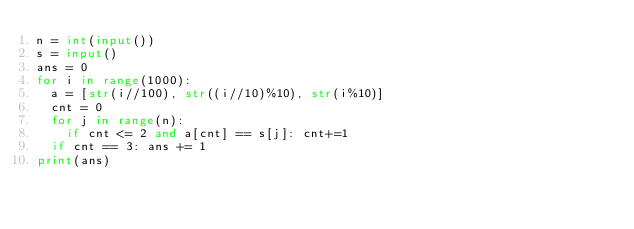Convert code to text. <code><loc_0><loc_0><loc_500><loc_500><_Python_>n = int(input())
s = input()
ans = 0
for i in range(1000):
  a = [str(i//100), str((i//10)%10), str(i%10)]
  cnt = 0
  for j in range(n):
    if cnt <= 2 and a[cnt] == s[j]: cnt+=1
  if cnt == 3: ans += 1
print(ans)</code> 